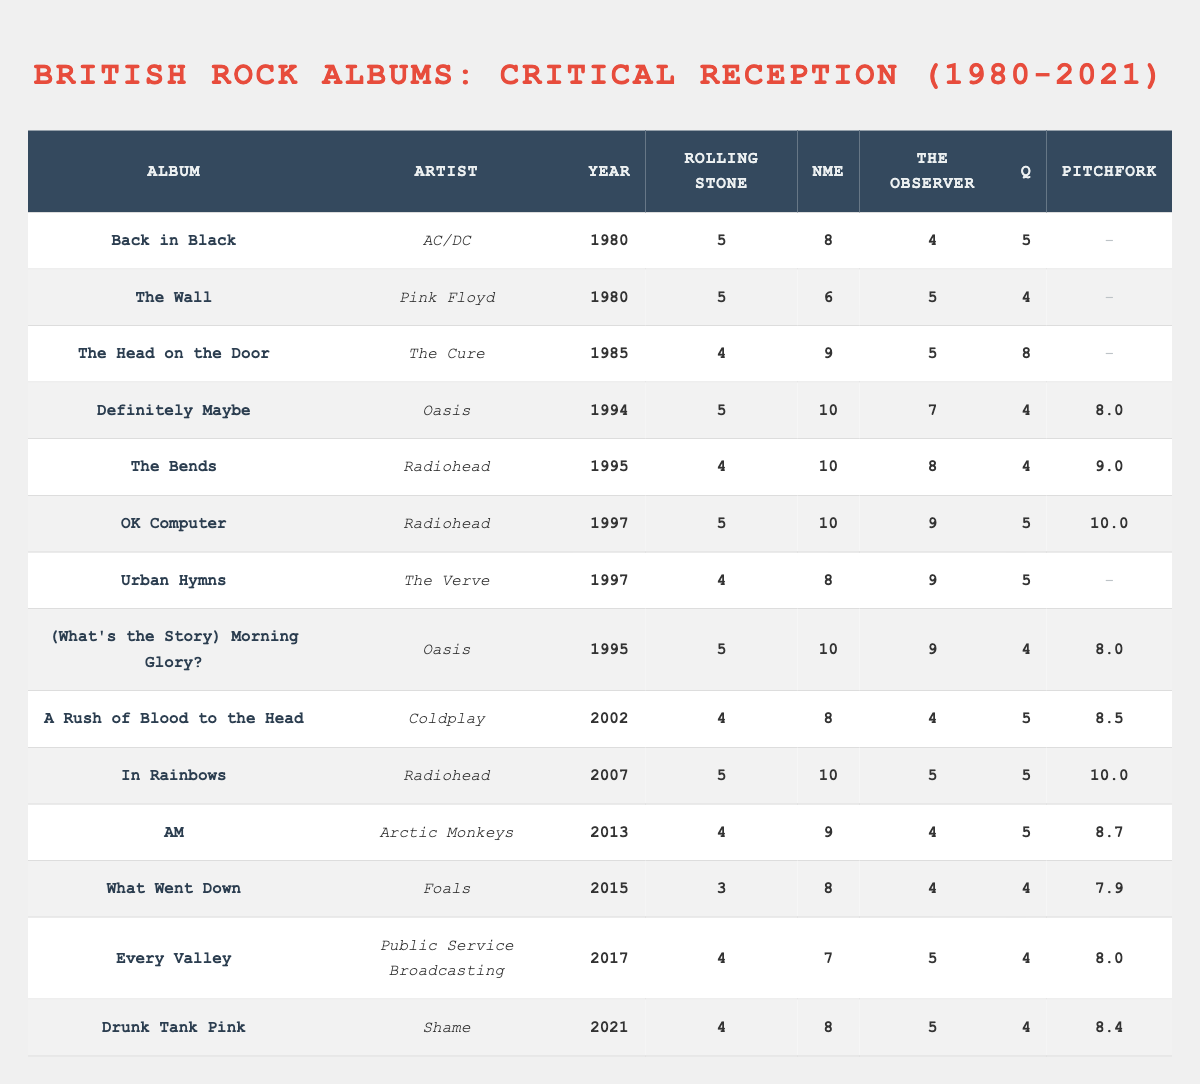What is the highest score received by Pink Floyd's album "The Wall"? In the table under the "The Wall" row, the scores are: Rolling Stone (5), NME (6), The Observer (5), Q (4). The highest score is 6 from NME.
Answer: 6 Which album received the highest average score from different publications? To find the highest average, calculate the scores for each album (excluding null values) and then average them. "OK Computer" has scores of 5, 10, 9, 5, and 10, which average to 7.8, the highest among all albums.
Answer: 7.8 Was "Definitely Maybe" by Oasis rated higher than "The Bends" by Radiohead in the NME publication? The NME score for "Definitely Maybe" is 10 while the score for "The Bends" is also 10. Since both are equal in NME, the statement is false.
Answer: No Which artist has the most albums listed in the table? By reviewing the artist column, Radiohead appears three times, including "The Bends," "OK Computer," and "In Rainbows." No other artist appears more than twice.
Answer: Radiohead What was the score given to Coldplay's album "A Rush of Blood to the Head" by Pitchfork? The "A Rush of Blood to the Head" row indicates that Pitchfork assigned a score of 8.5.
Answer: 8.5 Which album released in 1997 had the highest score from The Observer? In the table for 1997, "OK Computer" has a score of 9 from The Observer, while "Urban Hymns" has 9, therefore the highest score is shared by both.
Answer: 9 What is the total sum of scores given to the album "Urban Hymns" across all publications? Adding the scores for "Urban Hymns": Rolling Stone (4) + NME (8) + The Observer (9) + Q (5), which equals 26.
Answer: 26 Did "AM" by Arctic Monkeys receive a higher score from Q than "In Rainbows"? The scores indicate that "AM" received 5 from Q, while "In Rainbows" received 5 as well, making their scores equal and thus false for the statement.
Answer: No Which album had the lowest score from Rolling Stone? Reviewing the scores, "What Went Down" received the lowest score from Rolling Stone at 3.
Answer: 3 How many albums received a perfect score of 10 from Pitchfork? There are two albums listed with a Pitchfork score of 10: "OK Computer" and "In Rainbows." Thus, the total is 2.
Answer: 2 